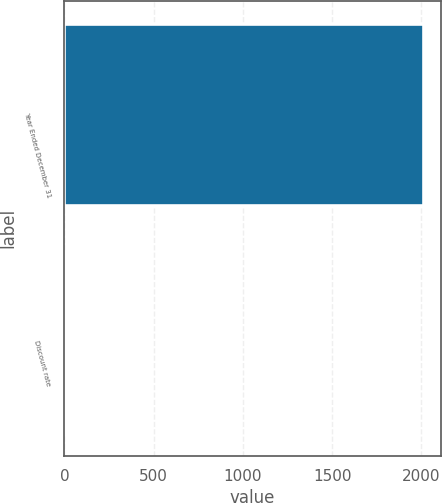Convert chart. <chart><loc_0><loc_0><loc_500><loc_500><bar_chart><fcel>Year Ended December 31<fcel>Discount rate<nl><fcel>2008<fcel>6<nl></chart> 